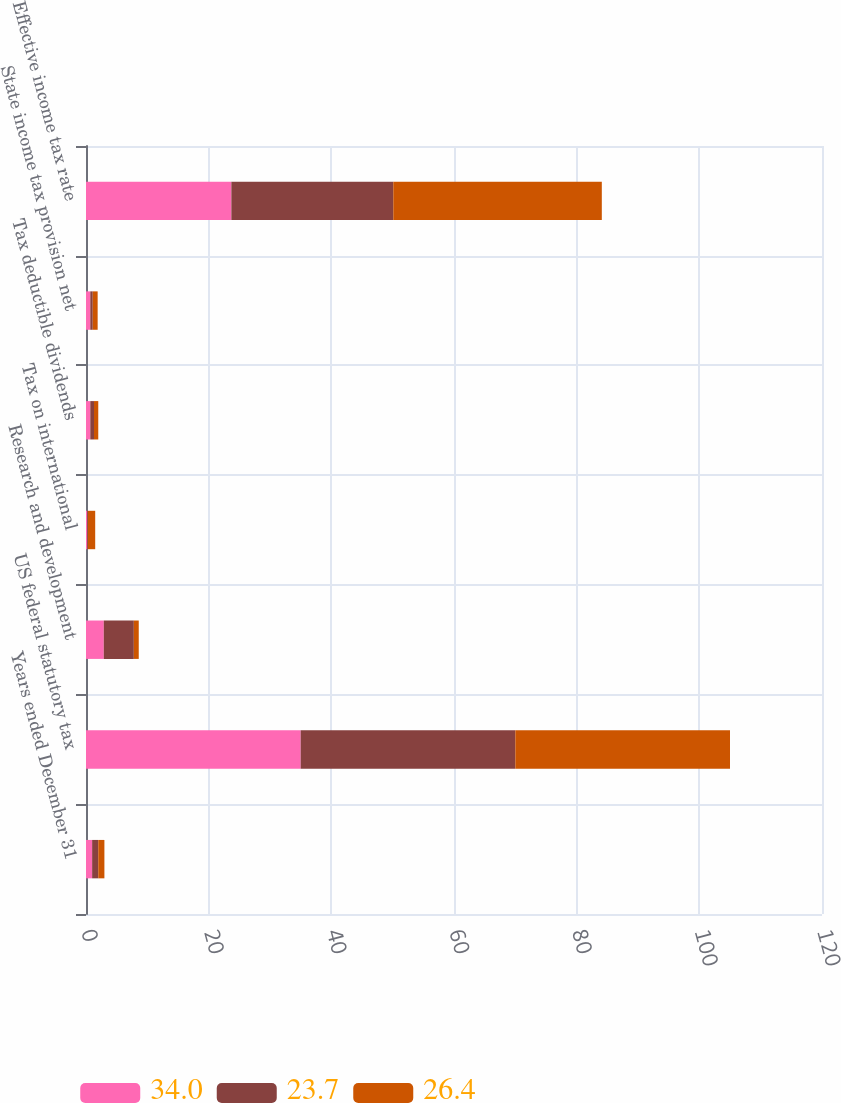Convert chart. <chart><loc_0><loc_0><loc_500><loc_500><stacked_bar_chart><ecel><fcel>Years ended December 31<fcel>US federal statutory tax<fcel>Research and development<fcel>Tax on international<fcel>Tax deductible dividends<fcel>State income tax provision net<fcel>Effective income tax rate<nl><fcel>34<fcel>1<fcel>35<fcel>2.9<fcel>0.2<fcel>0.7<fcel>0.7<fcel>23.7<nl><fcel>23.7<fcel>1<fcel>35<fcel>4.9<fcel>0.1<fcel>0.6<fcel>0.4<fcel>26.4<nl><fcel>26.4<fcel>1<fcel>35<fcel>0.8<fcel>1.2<fcel>0.7<fcel>0.8<fcel>34<nl></chart> 